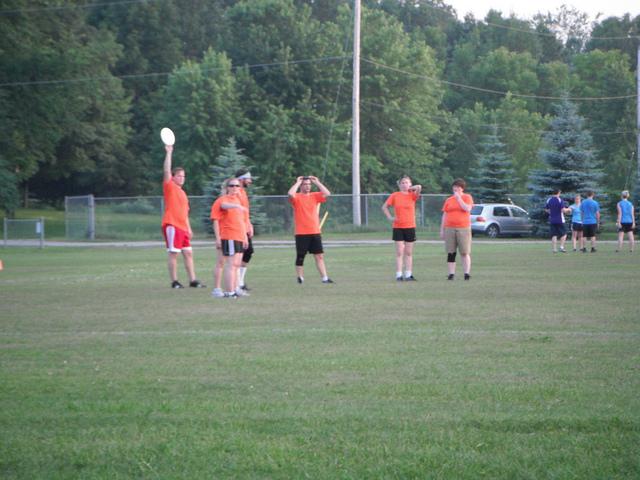How many teams are there?
Write a very short answer. 2. What color are the shirts?
Write a very short answer. Orange. What type of game are the people playing?
Give a very brief answer. Frisbee. 